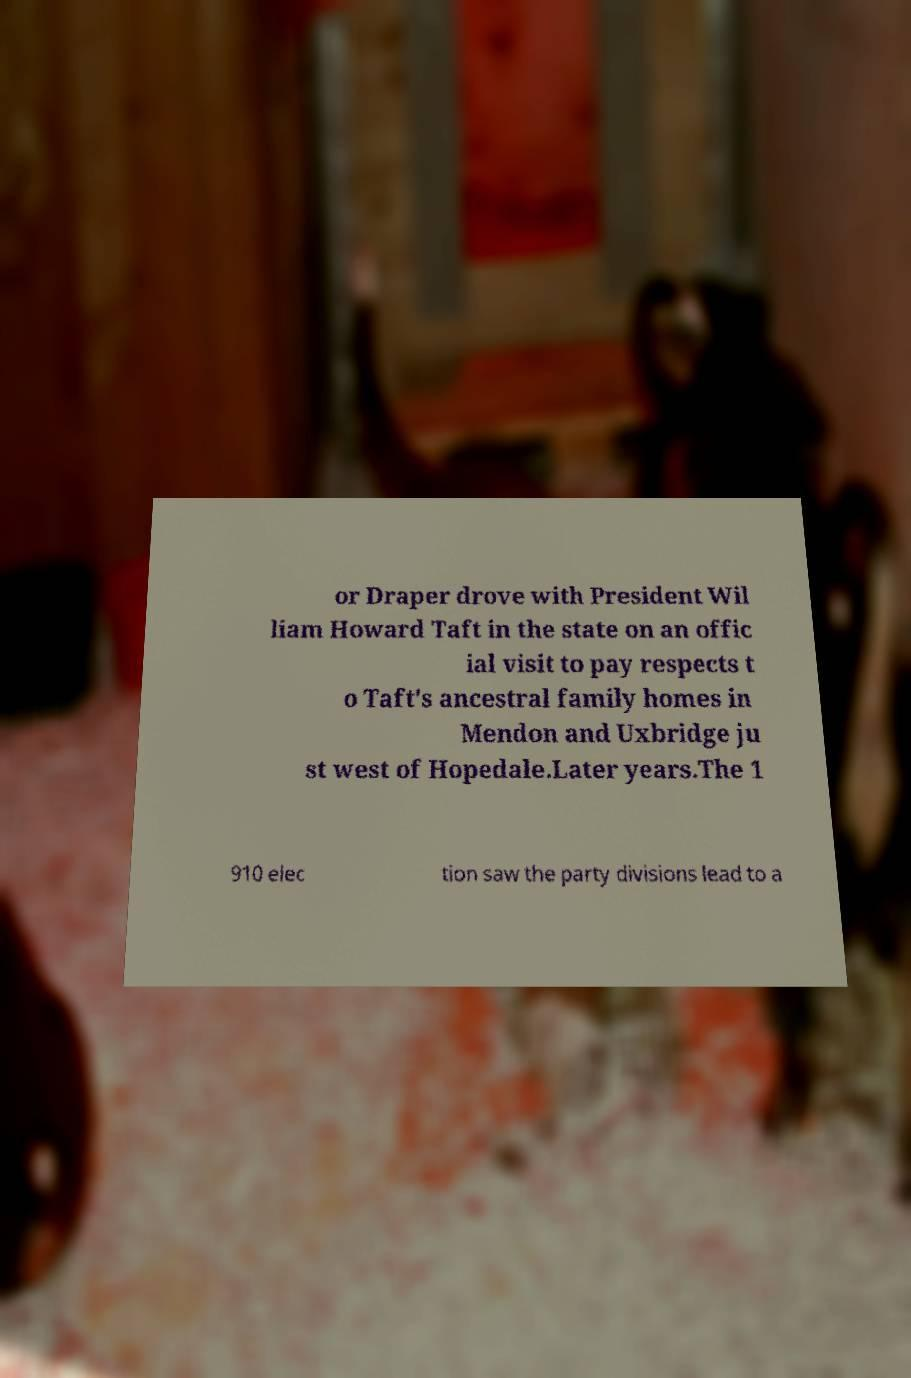Can you read and provide the text displayed in the image?This photo seems to have some interesting text. Can you extract and type it out for me? or Draper drove with President Wil liam Howard Taft in the state on an offic ial visit to pay respects t o Taft's ancestral family homes in Mendon and Uxbridge ju st west of Hopedale.Later years.The 1 910 elec tion saw the party divisions lead to a 